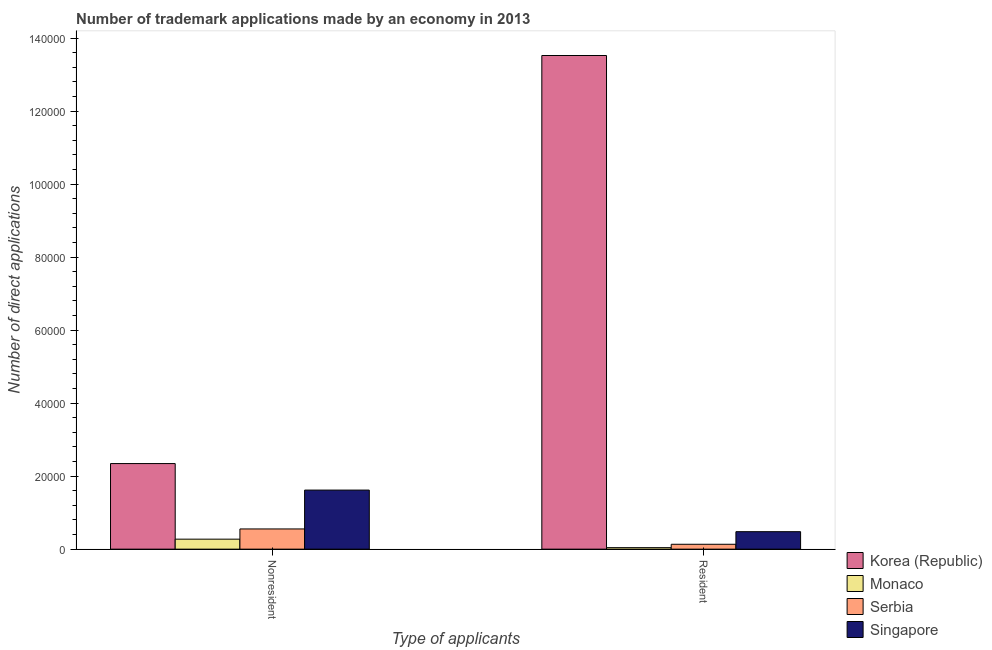Are the number of bars per tick equal to the number of legend labels?
Provide a succinct answer. Yes. How many bars are there on the 1st tick from the left?
Your response must be concise. 4. What is the label of the 2nd group of bars from the left?
Offer a terse response. Resident. What is the number of trademark applications made by residents in Singapore?
Offer a terse response. 4787. Across all countries, what is the maximum number of trademark applications made by non residents?
Your response must be concise. 2.34e+04. Across all countries, what is the minimum number of trademark applications made by non residents?
Your answer should be compact. 2737. In which country was the number of trademark applications made by residents maximum?
Keep it short and to the point. Korea (Republic). In which country was the number of trademark applications made by non residents minimum?
Keep it short and to the point. Monaco. What is the total number of trademark applications made by residents in the graph?
Offer a terse response. 1.42e+05. What is the difference between the number of trademark applications made by non residents in Singapore and that in Korea (Republic)?
Keep it short and to the point. -7265. What is the difference between the number of trademark applications made by non residents in Korea (Republic) and the number of trademark applications made by residents in Serbia?
Offer a terse response. 2.21e+04. What is the average number of trademark applications made by non residents per country?
Offer a very short reply. 1.20e+04. What is the difference between the number of trademark applications made by residents and number of trademark applications made by non residents in Serbia?
Provide a short and direct response. -4199. In how many countries, is the number of trademark applications made by residents greater than 20000 ?
Your response must be concise. 1. What is the ratio of the number of trademark applications made by non residents in Singapore to that in Monaco?
Provide a succinct answer. 5.91. Is the number of trademark applications made by residents in Korea (Republic) less than that in Serbia?
Your response must be concise. No. What does the 1st bar from the left in Nonresident represents?
Offer a very short reply. Korea (Republic). What does the 2nd bar from the right in Resident represents?
Offer a terse response. Serbia. How many bars are there?
Keep it short and to the point. 8. How many countries are there in the graph?
Ensure brevity in your answer.  4. Are the values on the major ticks of Y-axis written in scientific E-notation?
Keep it short and to the point. No. How are the legend labels stacked?
Your answer should be compact. Vertical. What is the title of the graph?
Your answer should be very brief. Number of trademark applications made by an economy in 2013. Does "Slovak Republic" appear as one of the legend labels in the graph?
Provide a short and direct response. No. What is the label or title of the X-axis?
Offer a terse response. Type of applicants. What is the label or title of the Y-axis?
Your answer should be very brief. Number of direct applications. What is the Number of direct applications of Korea (Republic) in Nonresident?
Provide a succinct answer. 2.34e+04. What is the Number of direct applications in Monaco in Nonresident?
Give a very brief answer. 2737. What is the Number of direct applications of Serbia in Nonresident?
Make the answer very short. 5534. What is the Number of direct applications in Singapore in Nonresident?
Offer a very short reply. 1.62e+04. What is the Number of direct applications in Korea (Republic) in Resident?
Keep it short and to the point. 1.35e+05. What is the Number of direct applications of Monaco in Resident?
Keep it short and to the point. 412. What is the Number of direct applications of Serbia in Resident?
Give a very brief answer. 1335. What is the Number of direct applications of Singapore in Resident?
Your answer should be very brief. 4787. Across all Type of applicants, what is the maximum Number of direct applications of Korea (Republic)?
Make the answer very short. 1.35e+05. Across all Type of applicants, what is the maximum Number of direct applications of Monaco?
Your answer should be compact. 2737. Across all Type of applicants, what is the maximum Number of direct applications in Serbia?
Give a very brief answer. 5534. Across all Type of applicants, what is the maximum Number of direct applications of Singapore?
Ensure brevity in your answer.  1.62e+04. Across all Type of applicants, what is the minimum Number of direct applications of Korea (Republic)?
Offer a very short reply. 2.34e+04. Across all Type of applicants, what is the minimum Number of direct applications of Monaco?
Ensure brevity in your answer.  412. Across all Type of applicants, what is the minimum Number of direct applications in Serbia?
Offer a terse response. 1335. Across all Type of applicants, what is the minimum Number of direct applications in Singapore?
Provide a short and direct response. 4787. What is the total Number of direct applications in Korea (Republic) in the graph?
Offer a terse response. 1.59e+05. What is the total Number of direct applications of Monaco in the graph?
Give a very brief answer. 3149. What is the total Number of direct applications in Serbia in the graph?
Your answer should be very brief. 6869. What is the total Number of direct applications in Singapore in the graph?
Offer a very short reply. 2.10e+04. What is the difference between the Number of direct applications of Korea (Republic) in Nonresident and that in Resident?
Keep it short and to the point. -1.12e+05. What is the difference between the Number of direct applications of Monaco in Nonresident and that in Resident?
Offer a very short reply. 2325. What is the difference between the Number of direct applications in Serbia in Nonresident and that in Resident?
Provide a succinct answer. 4199. What is the difference between the Number of direct applications of Singapore in Nonresident and that in Resident?
Your response must be concise. 1.14e+04. What is the difference between the Number of direct applications in Korea (Republic) in Nonresident and the Number of direct applications in Monaco in Resident?
Provide a short and direct response. 2.30e+04. What is the difference between the Number of direct applications of Korea (Republic) in Nonresident and the Number of direct applications of Serbia in Resident?
Give a very brief answer. 2.21e+04. What is the difference between the Number of direct applications in Korea (Republic) in Nonresident and the Number of direct applications in Singapore in Resident?
Give a very brief answer. 1.87e+04. What is the difference between the Number of direct applications of Monaco in Nonresident and the Number of direct applications of Serbia in Resident?
Provide a succinct answer. 1402. What is the difference between the Number of direct applications of Monaco in Nonresident and the Number of direct applications of Singapore in Resident?
Your answer should be very brief. -2050. What is the difference between the Number of direct applications of Serbia in Nonresident and the Number of direct applications of Singapore in Resident?
Ensure brevity in your answer.  747. What is the average Number of direct applications of Korea (Republic) per Type of applicants?
Give a very brief answer. 7.93e+04. What is the average Number of direct applications of Monaco per Type of applicants?
Ensure brevity in your answer.  1574.5. What is the average Number of direct applications of Serbia per Type of applicants?
Your response must be concise. 3434.5. What is the average Number of direct applications in Singapore per Type of applicants?
Your answer should be compact. 1.05e+04. What is the difference between the Number of direct applications in Korea (Republic) and Number of direct applications in Monaco in Nonresident?
Make the answer very short. 2.07e+04. What is the difference between the Number of direct applications of Korea (Republic) and Number of direct applications of Serbia in Nonresident?
Make the answer very short. 1.79e+04. What is the difference between the Number of direct applications in Korea (Republic) and Number of direct applications in Singapore in Nonresident?
Provide a short and direct response. 7265. What is the difference between the Number of direct applications in Monaco and Number of direct applications in Serbia in Nonresident?
Your answer should be very brief. -2797. What is the difference between the Number of direct applications of Monaco and Number of direct applications of Singapore in Nonresident?
Ensure brevity in your answer.  -1.34e+04. What is the difference between the Number of direct applications in Serbia and Number of direct applications in Singapore in Nonresident?
Ensure brevity in your answer.  -1.06e+04. What is the difference between the Number of direct applications of Korea (Republic) and Number of direct applications of Monaco in Resident?
Offer a terse response. 1.35e+05. What is the difference between the Number of direct applications in Korea (Republic) and Number of direct applications in Serbia in Resident?
Make the answer very short. 1.34e+05. What is the difference between the Number of direct applications in Korea (Republic) and Number of direct applications in Singapore in Resident?
Your response must be concise. 1.30e+05. What is the difference between the Number of direct applications in Monaco and Number of direct applications in Serbia in Resident?
Your answer should be compact. -923. What is the difference between the Number of direct applications in Monaco and Number of direct applications in Singapore in Resident?
Your answer should be compact. -4375. What is the difference between the Number of direct applications in Serbia and Number of direct applications in Singapore in Resident?
Your answer should be very brief. -3452. What is the ratio of the Number of direct applications in Korea (Republic) in Nonresident to that in Resident?
Give a very brief answer. 0.17. What is the ratio of the Number of direct applications of Monaco in Nonresident to that in Resident?
Offer a terse response. 6.64. What is the ratio of the Number of direct applications of Serbia in Nonresident to that in Resident?
Ensure brevity in your answer.  4.15. What is the ratio of the Number of direct applications in Singapore in Nonresident to that in Resident?
Offer a very short reply. 3.38. What is the difference between the highest and the second highest Number of direct applications of Korea (Republic)?
Offer a very short reply. 1.12e+05. What is the difference between the highest and the second highest Number of direct applications of Monaco?
Ensure brevity in your answer.  2325. What is the difference between the highest and the second highest Number of direct applications in Serbia?
Give a very brief answer. 4199. What is the difference between the highest and the second highest Number of direct applications in Singapore?
Make the answer very short. 1.14e+04. What is the difference between the highest and the lowest Number of direct applications in Korea (Republic)?
Keep it short and to the point. 1.12e+05. What is the difference between the highest and the lowest Number of direct applications of Monaco?
Provide a short and direct response. 2325. What is the difference between the highest and the lowest Number of direct applications in Serbia?
Make the answer very short. 4199. What is the difference between the highest and the lowest Number of direct applications in Singapore?
Offer a terse response. 1.14e+04. 